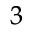Convert formula to latex. <formula><loc_0><loc_0><loc_500><loc_500>^ { 3 }</formula> 